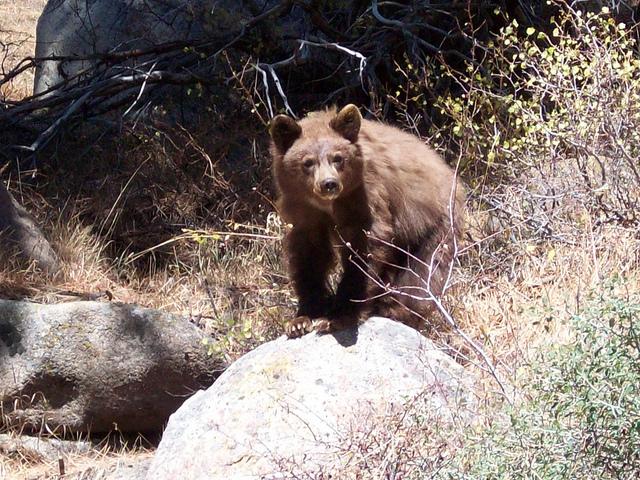What color is the bear?
Short answer required. Brown. Is the bear sad?
Short answer required. No. Is the bear full grown?
Answer briefly. No. Can you see the bear's shadow?
Concise answer only. Yes. 